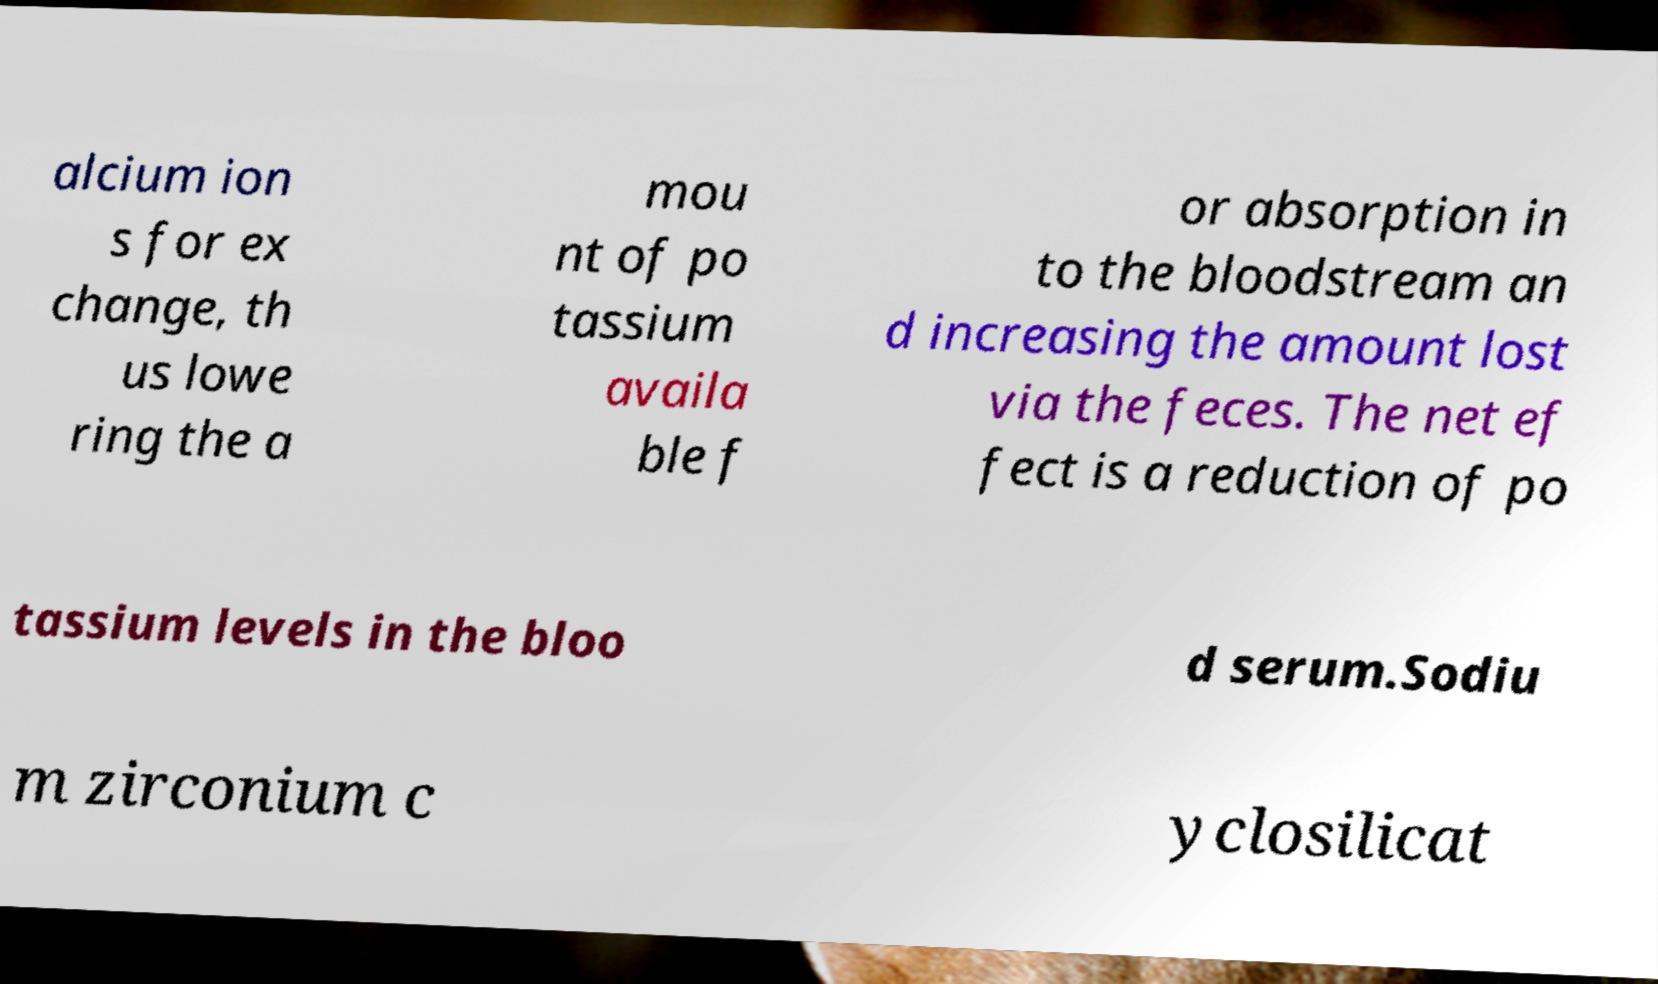Can you accurately transcribe the text from the provided image for me? alcium ion s for ex change, th us lowe ring the a mou nt of po tassium availa ble f or absorption in to the bloodstream an d increasing the amount lost via the feces. The net ef fect is a reduction of po tassium levels in the bloo d serum.Sodiu m zirconium c yclosilicat 